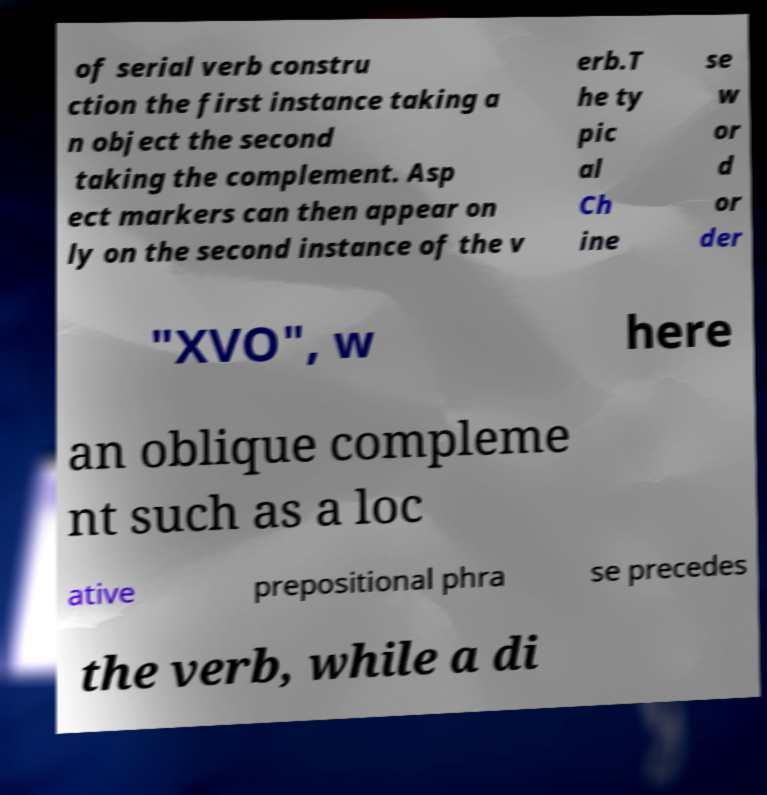Could you assist in decoding the text presented in this image and type it out clearly? of serial verb constru ction the first instance taking a n object the second taking the complement. Asp ect markers can then appear on ly on the second instance of the v erb.T he ty pic al Ch ine se w or d or der "XVO", w here an oblique compleme nt such as a loc ative prepositional phra se precedes the verb, while a di 